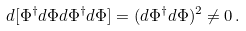<formula> <loc_0><loc_0><loc_500><loc_500>d [ \Phi ^ { \dagger } d \Phi d \Phi ^ { \dagger } d \Phi ] = ( d \Phi ^ { \dagger } d \Phi ) ^ { 2 } \ne 0 \, .</formula> 